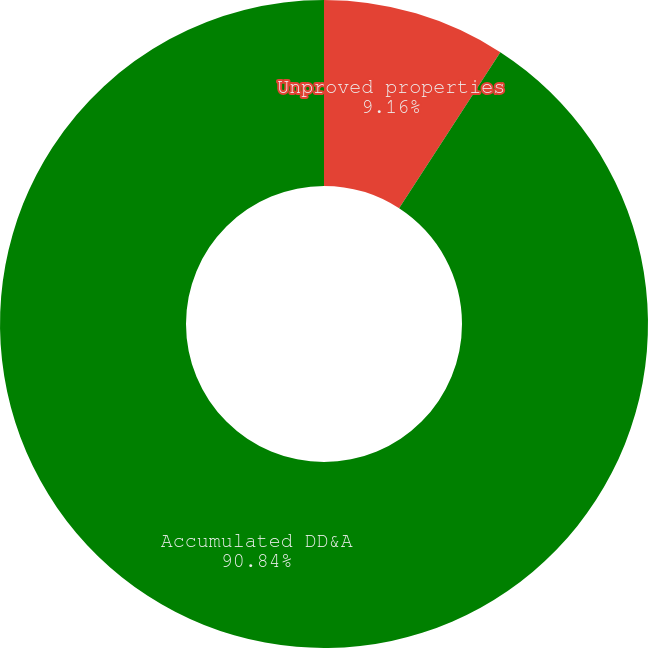Convert chart. <chart><loc_0><loc_0><loc_500><loc_500><pie_chart><fcel>Unproved properties<fcel>Accumulated DD&A<nl><fcel>9.16%<fcel>90.84%<nl></chart> 